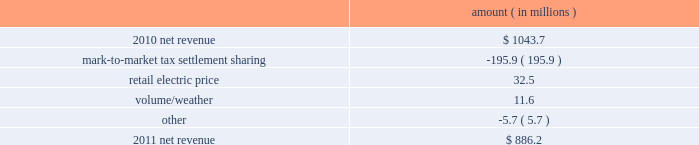Entergy louisiana , llc and subsidiaries management 2019s financial discussion and analysis plan to spin off the utility 2019s transmission business see the 201cplan to spin off the utility 2019s transmission business 201d section of entergy corporation and subsidiaries management 2019s financial discussion and analysis for a discussion of this matter , including the planned retirement of debt and preferred securities .
Results of operations net income 2011 compared to 2010 net income increased $ 242.5 million primarily due to a settlement with the irs related to the mark-to-market income tax treatment of power purchase contracts , which resulted in a $ 422 million income tax benefit .
The net income effect was partially offset by a $ 199 million regulatory charge , which reduced net revenue , because a portion of the benefit will be shared with customers .
See note 3 to the financial statements for additional discussion of the settlement and benefit sharing .
2010 compared to 2009 net income decreased slightly by $ 1.4 million primarily due to higher other operation and maintenance expenses , a higher effective income tax rate , and higher interest expense , almost entirely offset by higher net revenue .
Net revenue 2011 compared to 2010 net revenue consists of operating revenues net of : 1 ) fuel , fuel-related expenses , and gas purchased for resale , 2 ) purchased power expenses , and 3 ) other regulatory charges ( credits ) .
Following is an analysis of the change in net revenue comparing 2011 to 2010 .
Amount ( in millions ) .
The mark-to-market tax settlement sharing variance results from a regulatory charge because a portion of the benefits of a settlement with the irs related to the mark-to-market income tax treatment of power purchase contracts will be shared with customers , slightly offset by the amortization of a portion of that charge beginning in october 2011 .
See notes 3 and 8 to the financial statements for additional discussion of the settlement and benefit sharing .
The retail electric price variance is primarily due to a formula rate plan increase effective may 2011 .
See note 2 to the financial statements for discussion of the formula rate plan increase. .
What was the percent of the change in the net revenue from 2010 to 2011? 
Computations: ((886.2 - 1043.7) / 1043.7)
Answer: -0.15091. 